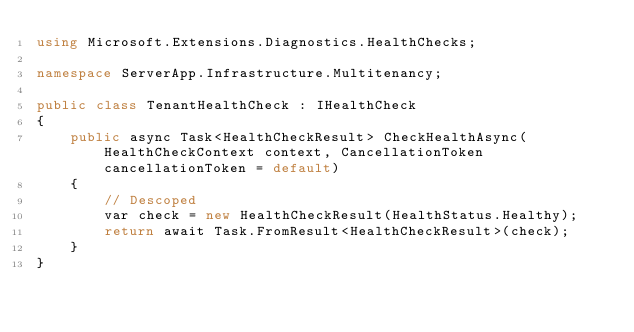<code> <loc_0><loc_0><loc_500><loc_500><_C#_>using Microsoft.Extensions.Diagnostics.HealthChecks;

namespace ServerApp.Infrastructure.Multitenancy;

public class TenantHealthCheck : IHealthCheck
{
    public async Task<HealthCheckResult> CheckHealthAsync(HealthCheckContext context, CancellationToken cancellationToken = default)
    {
        // Descoped
        var check = new HealthCheckResult(HealthStatus.Healthy);
        return await Task.FromResult<HealthCheckResult>(check);
    }
}</code> 